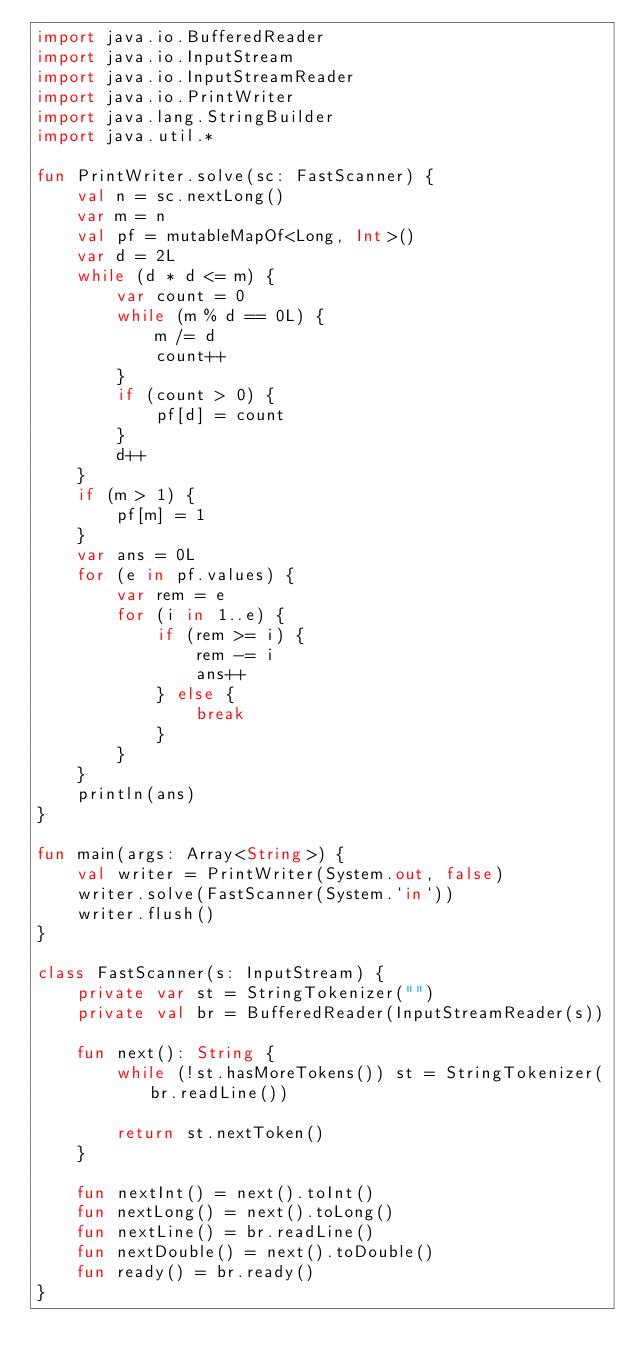Convert code to text. <code><loc_0><loc_0><loc_500><loc_500><_Kotlin_>import java.io.BufferedReader
import java.io.InputStream
import java.io.InputStreamReader
import java.io.PrintWriter
import java.lang.StringBuilder
import java.util.*

fun PrintWriter.solve(sc: FastScanner) {
    val n = sc.nextLong()
    var m = n
    val pf = mutableMapOf<Long, Int>()
    var d = 2L
    while (d * d <= m) {
        var count = 0
        while (m % d == 0L) {
            m /= d
            count++
        }
        if (count > 0) {
            pf[d] = count
        }
        d++
    }
    if (m > 1) {
        pf[m] = 1
    }
    var ans = 0L
    for (e in pf.values) {
        var rem = e
        for (i in 1..e) {
            if (rem >= i) {
                rem -= i
                ans++
            } else {
                break
            }
        }
    }
    println(ans)
}

fun main(args: Array<String>) {
    val writer = PrintWriter(System.out, false)
    writer.solve(FastScanner(System.`in`))
    writer.flush()
}

class FastScanner(s: InputStream) {
    private var st = StringTokenizer("")
    private val br = BufferedReader(InputStreamReader(s))

    fun next(): String {
        while (!st.hasMoreTokens()) st = StringTokenizer(br.readLine())

        return st.nextToken()
    }

    fun nextInt() = next().toInt()
    fun nextLong() = next().toLong()
    fun nextLine() = br.readLine()
    fun nextDouble() = next().toDouble()
    fun ready() = br.ready()
}
</code> 